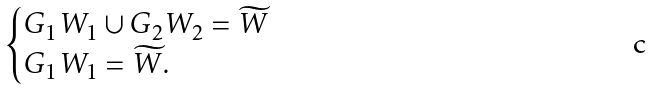Convert formula to latex. <formula><loc_0><loc_0><loc_500><loc_500>\begin{cases} G _ { 1 } W _ { 1 } \cup G _ { 2 } W _ { 2 } = \widetilde { W } \\ G _ { 1 } W _ { 1 } = \widetilde { W } . \end{cases}</formula> 